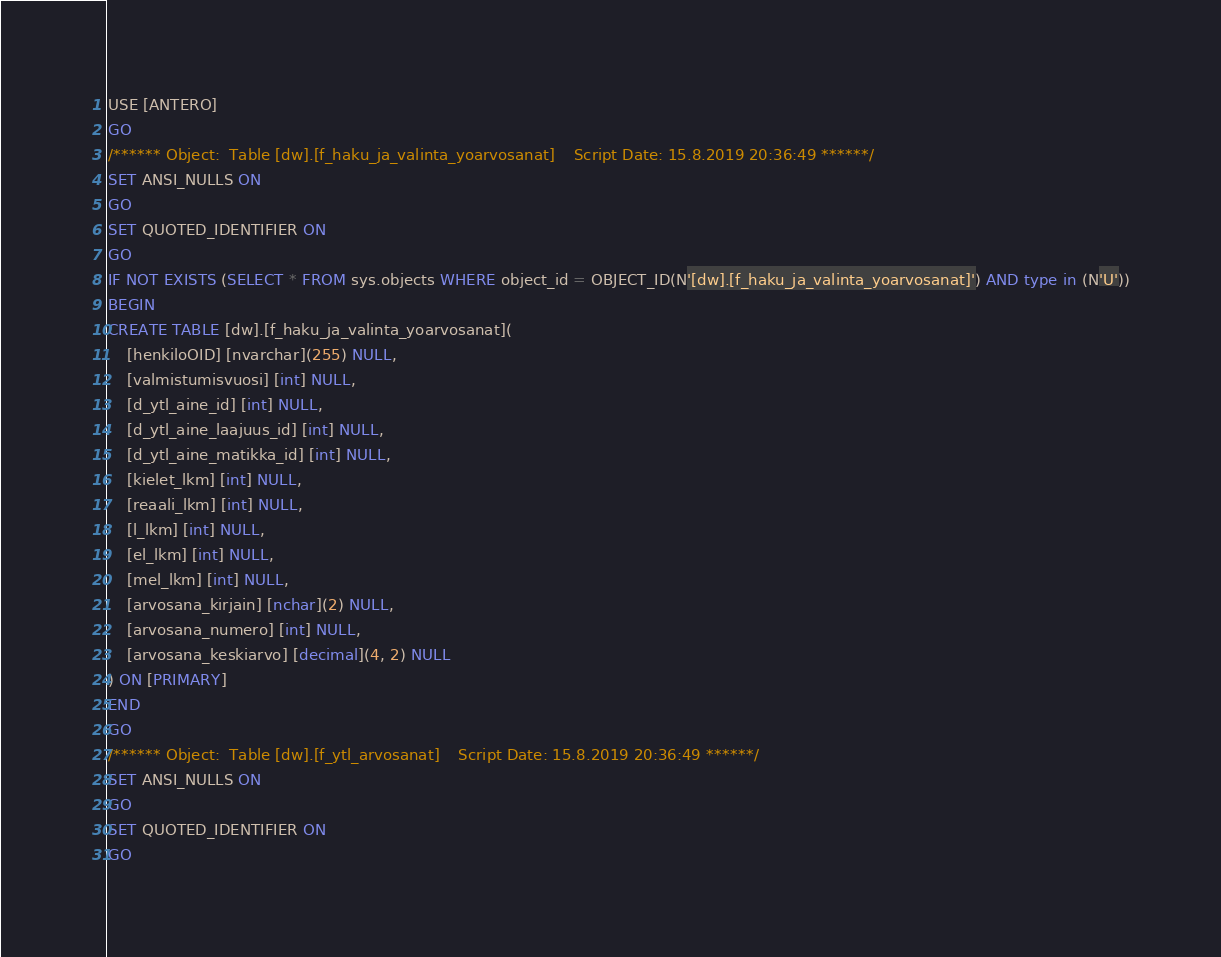<code> <loc_0><loc_0><loc_500><loc_500><_SQL_>USE [ANTERO]
GO
/****** Object:  Table [dw].[f_haku_ja_valinta_yoarvosanat]    Script Date: 15.8.2019 20:36:49 ******/
SET ANSI_NULLS ON
GO
SET QUOTED_IDENTIFIER ON
GO
IF NOT EXISTS (SELECT * FROM sys.objects WHERE object_id = OBJECT_ID(N'[dw].[f_haku_ja_valinta_yoarvosanat]') AND type in (N'U'))
BEGIN
CREATE TABLE [dw].[f_haku_ja_valinta_yoarvosanat](
	[henkiloOID] [nvarchar](255) NULL,
	[valmistumisvuosi] [int] NULL,
	[d_ytl_aine_id] [int] NULL,
	[d_ytl_aine_laajuus_id] [int] NULL,
	[d_ytl_aine_matikka_id] [int] NULL,
	[kielet_lkm] [int] NULL,
	[reaali_lkm] [int] NULL,
	[l_lkm] [int] NULL,
	[el_lkm] [int] NULL,
	[mel_lkm] [int] NULL,
	[arvosana_kirjain] [nchar](2) NULL,
	[arvosana_numero] [int] NULL,
	[arvosana_keskiarvo] [decimal](4, 2) NULL
) ON [PRIMARY]
END
GO
/****** Object:  Table [dw].[f_ytl_arvosanat]    Script Date: 15.8.2019 20:36:49 ******/
SET ANSI_NULLS ON
GO
SET QUOTED_IDENTIFIER ON
GO</code> 